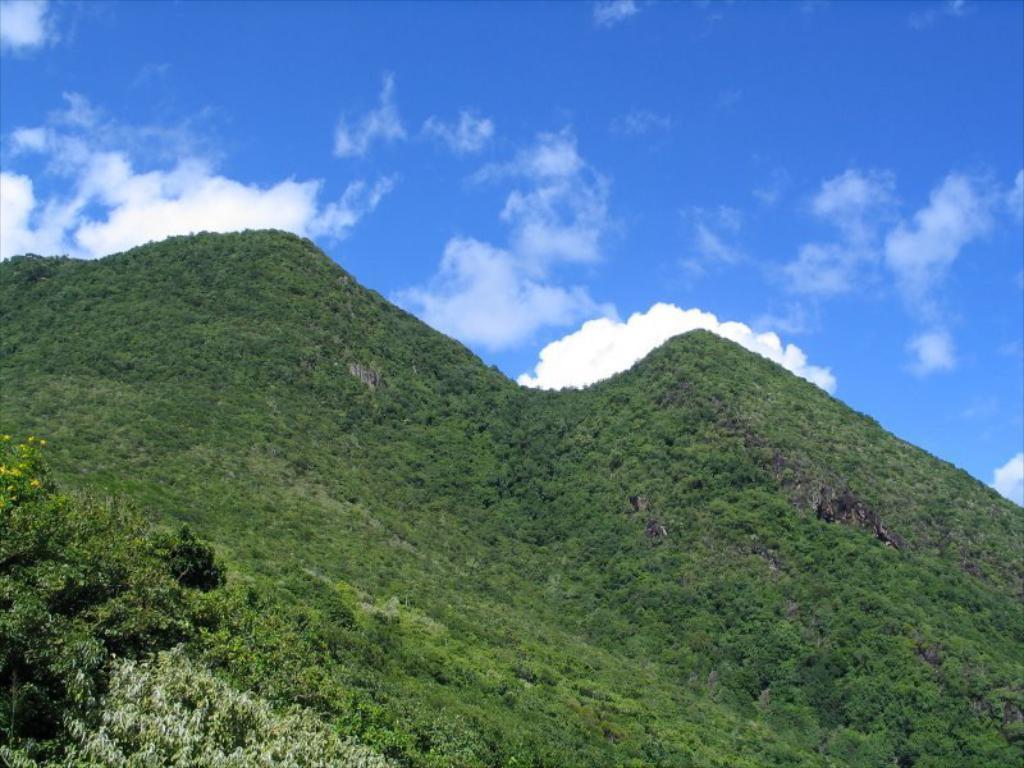Can you describe this image briefly? In this image we can see mount scenery that includes greenery surface and blue sky. 